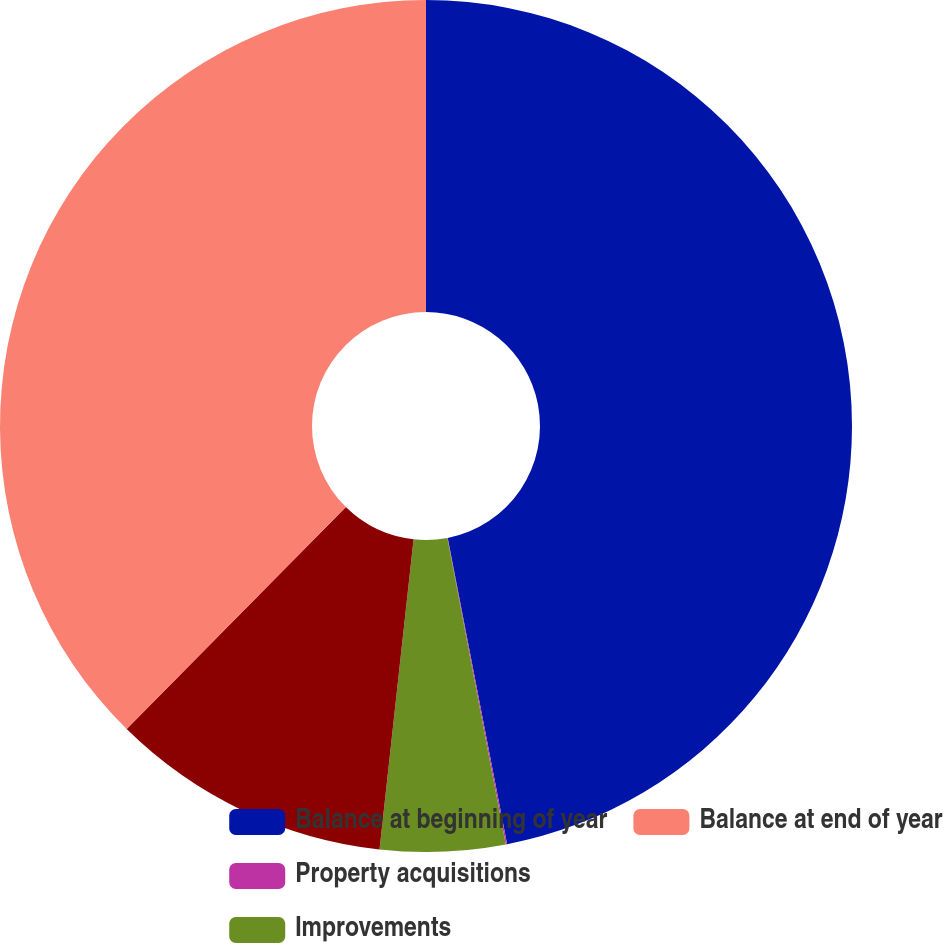Convert chart. <chart><loc_0><loc_0><loc_500><loc_500><pie_chart><fcel>Balance at beginning of year<fcel>Property acquisitions<fcel>Improvements<fcel>Unnamed: 3<fcel>Balance at end of year<nl><fcel>46.95%<fcel>0.05%<fcel>4.74%<fcel>10.66%<fcel>37.6%<nl></chart> 